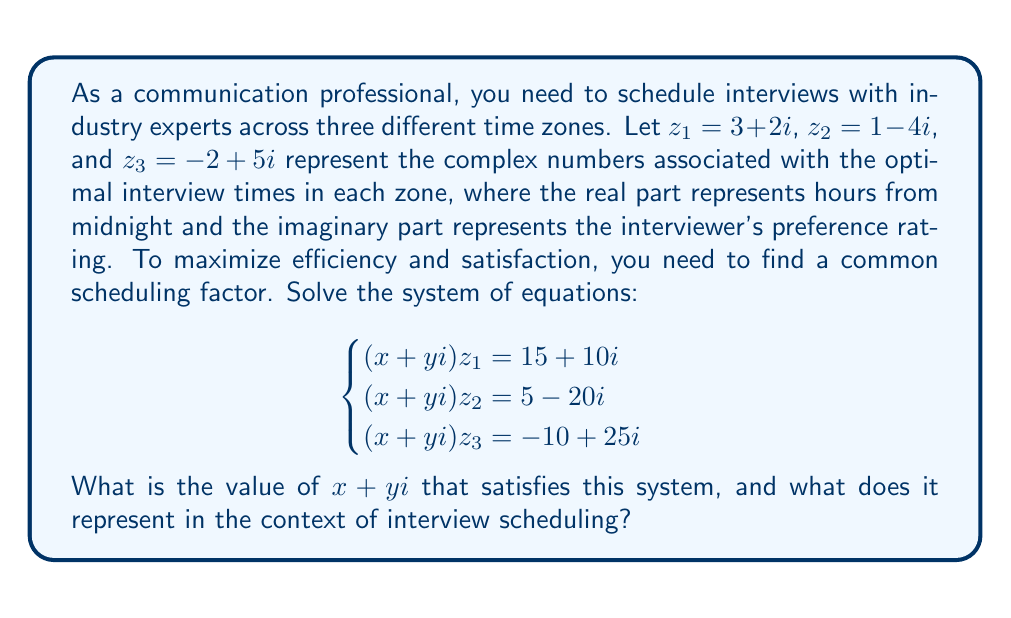What is the answer to this math problem? Let's solve this step-by-step:

1) We have three equations:
   $$(x+yi)(3+2i) = 15+10i$$
   $$(x+yi)(1-4i) = 5-20i$$
   $$(x+yi)(-2+5i) = -10+25i$$

2) Let's expand the first equation:
   $$3x-2y + (3y+2x)i = 15+10i$$
   Equating real and imaginary parts:
   $$3x-2y = 15$$
   $$3y+2x = 10$$

3) From the second equation:
   $$x+4y + (y-4x)i = 5-20i$$
   $$x+4y = 5$$
   $$y-4x = -20$$

4) From the third equation:
   $$-2x-5y + (-2y+5x)i = -10+25i$$
   $$-2x-5y = -10$$
   $$-2y+5x = 25$$

5) We now have a system of 6 equations with 2 unknowns. If a solution exists, it should satisfy all equations. Let's solve using the first two equations:

   $$3x-2y = 15$$
   $$3y+2x = 10$$

   Multiplying the first by 3 and the second by 2:
   $$9x-6y = 45$$
   $$6y+4x = 20$$

   Adding these:
   $$13x = 65$$
   $$x = 5$$

   Substituting back:
   $$3(5)-2y = 15$$
   $$15-2y = 15$$
   $$-2y = 0$$
   $$y = 0$$

6) Let's verify this solution $(x=5, y=0)$ satisfies all other equations:

   For eq.2: $5+4(0) = 5$ and $0-4(5) = -20$ ✓
   For eq.3: $-2(5)-5(0) = -10$ and $-2(0)+5(5) = 25$ ✓

Therefore, $x+yi = 5+0i = 5$ is the solution.

In the context of interview scheduling, this means:
- Multiply the real part of each $z_i$ by 5 to get the optimal interview time in hours from midnight.
- Multiply the imaginary part of each $z_i$ by 5 to get the scaled preference rating.

For example, for $z_1 = 3+2i$:
- Optimal time: $3 * 5 = 15$ hours from midnight (3 PM)
- Scaled preference: $2 * 5 = 10$
Answer: $x+yi = 5+0i = 5$

This represents a scaling factor for the interview times and preference ratings. Multiply the real part of each complex number by 5 to get the optimal interview time in hours from midnight, and multiply the imaginary part by 5 to get the scaled preference rating. 